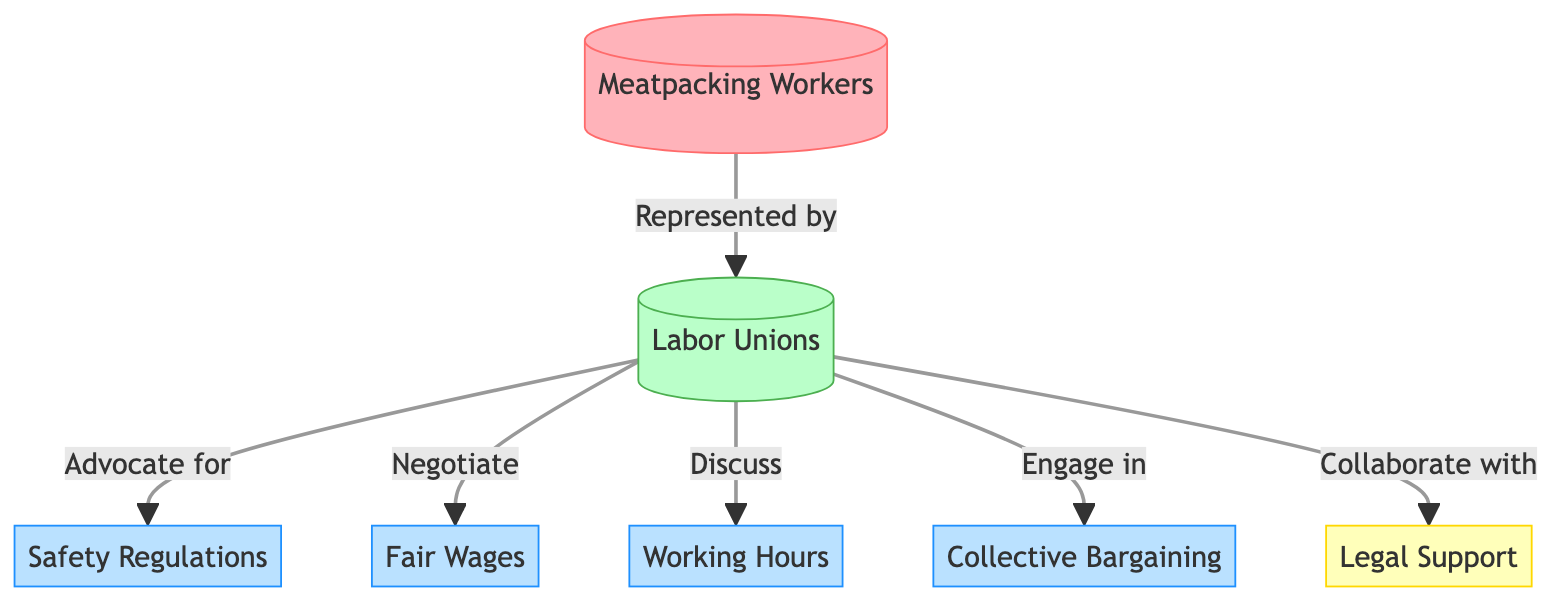What is the main group represented in the diagram? The diagram is centered around meatpacking workers, who are the primary group being represented. This is indicated by the first node labeled “Meatpacking Workers.”
Answer: Meatpacking Workers How many rights are directly associated with the labor unions? The diagram shows a total of four rights connected to labor unions: safety regulations, fair wages, working hours, and collective bargaining. These rights are displayed in individual nodes linked to the Labor Unions node.
Answer: Four What type of support do labor unions provide for workers? Labor unions provide legal support for workers, as indicated by the direct link from the Labor Unions node to the Legal Support node in the diagram.
Answer: Legal Support Which node describes the process of negotiation related to wages? The process of negotiating wages is described by the “Negotiate” link connecting Labor Unions to Fair Wages, illustrating the union’s role in advocating for better compensation.
Answer: Fair Wages What governs the advocacy role of labor unions? The advocacy role of labor unions is governed by safety regulations, as shown by the direct link from Labor Unions to Safety Regulations, signifying the unions' focus on ensuring safe working conditions for meatpacking workers.
Answer: Safety Regulations How many total relationships are shown between the nodes? There are six relationships indicated in the diagram that link the Labor Unions node to various rights and forms of support, counted from the edges connecting to each of the associated rights and the legal support node.
Answer: Six Which node is related to the legal aspect of workers’ rights? The legal aspect of workers’ rights is represented by the “Legal Support” node, which is connected to the Labor Unions node, indicating union involvement in providing this support.
Answer: Legal Support What are the main topics discussed by the labor unions as shown in the diagram? The main topics discussed by labor unions include fair wages, working hours, collective bargaining, and safety regulations, all represented as links from the Labor Unions node.
Answer: Fair wages, working hours, collective bargaining, safety regulations 